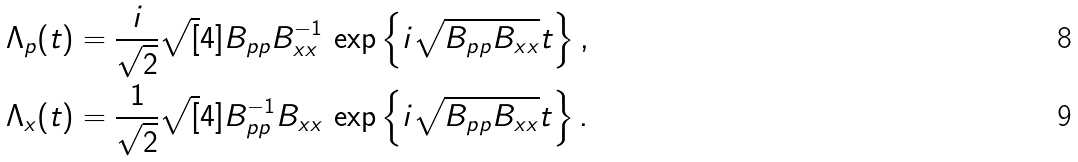Convert formula to latex. <formula><loc_0><loc_0><loc_500><loc_500>\Lambda _ { p } ( t ) & = \frac { i } { \sqrt { 2 } } \sqrt { [ } 4 ] { B _ { p p } B ^ { - 1 } _ { x x } } \, \exp \left \{ i \sqrt { B _ { p p } B _ { x x } } t \right \} , \\ \Lambda _ { x } ( t ) & = \frac { 1 } { \sqrt { 2 } } \sqrt { [ } 4 ] { B ^ { - 1 } _ { p p } B _ { x x } } \, \exp \left \{ i \sqrt { B _ { p p } B _ { x x } } t \right \} .</formula> 